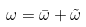Convert formula to latex. <formula><loc_0><loc_0><loc_500><loc_500>\omega = \bar { \omega } + \tilde { \omega }</formula> 